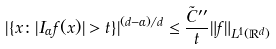<formula> <loc_0><loc_0><loc_500><loc_500>| \{ x \colon | I _ { \alpha } f ( x ) | > t \} | ^ { ( d - \alpha ) / d } \leq \frac { \tilde { C } ^ { \prime \prime } } { t } \| f \| _ { L ^ { 1 } ( \mathbb { R } ^ { d } ) }</formula> 